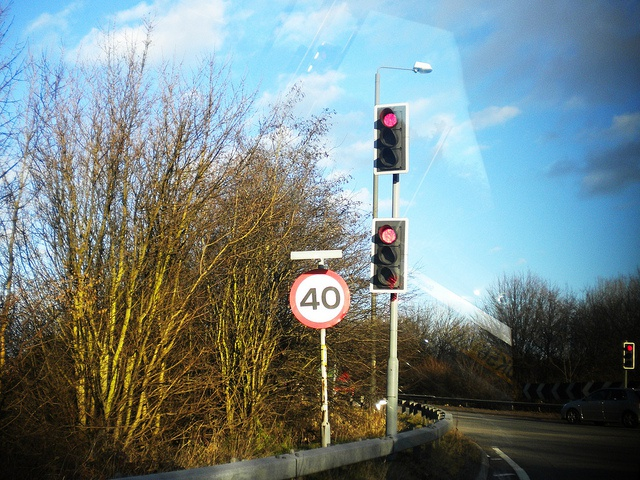Describe the objects in this image and their specific colors. I can see traffic light in lightblue, black, gray, ivory, and darkgray tones, traffic light in lightblue, black, gray, and darkgray tones, car in lightblue, black, and gray tones, car in lightblue, black, maroon, olive, and brown tones, and traffic light in lightblue, black, khaki, tan, and red tones in this image. 